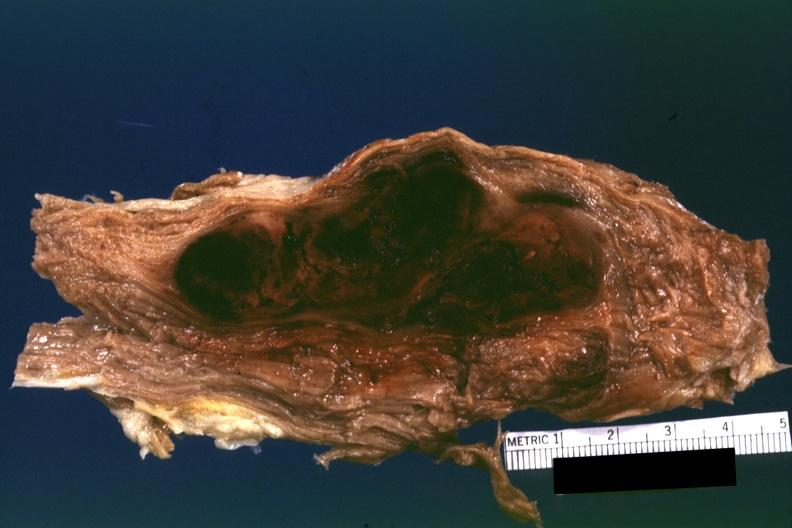what is what this appears to be in a psoas muscle if so the diagnosis on all other slides of this case in this file needs to be changed?
Answer the question using a single word or phrase. This 